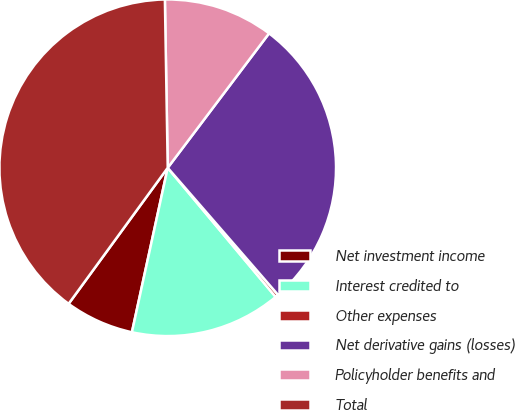Convert chart to OTSL. <chart><loc_0><loc_0><loc_500><loc_500><pie_chart><fcel>Net investment income<fcel>Interest credited to<fcel>Other expenses<fcel>Net derivative gains (losses)<fcel>Policyholder benefits and<fcel>Total<nl><fcel>6.61%<fcel>14.49%<fcel>0.3%<fcel>28.34%<fcel>10.55%<fcel>39.71%<nl></chart> 